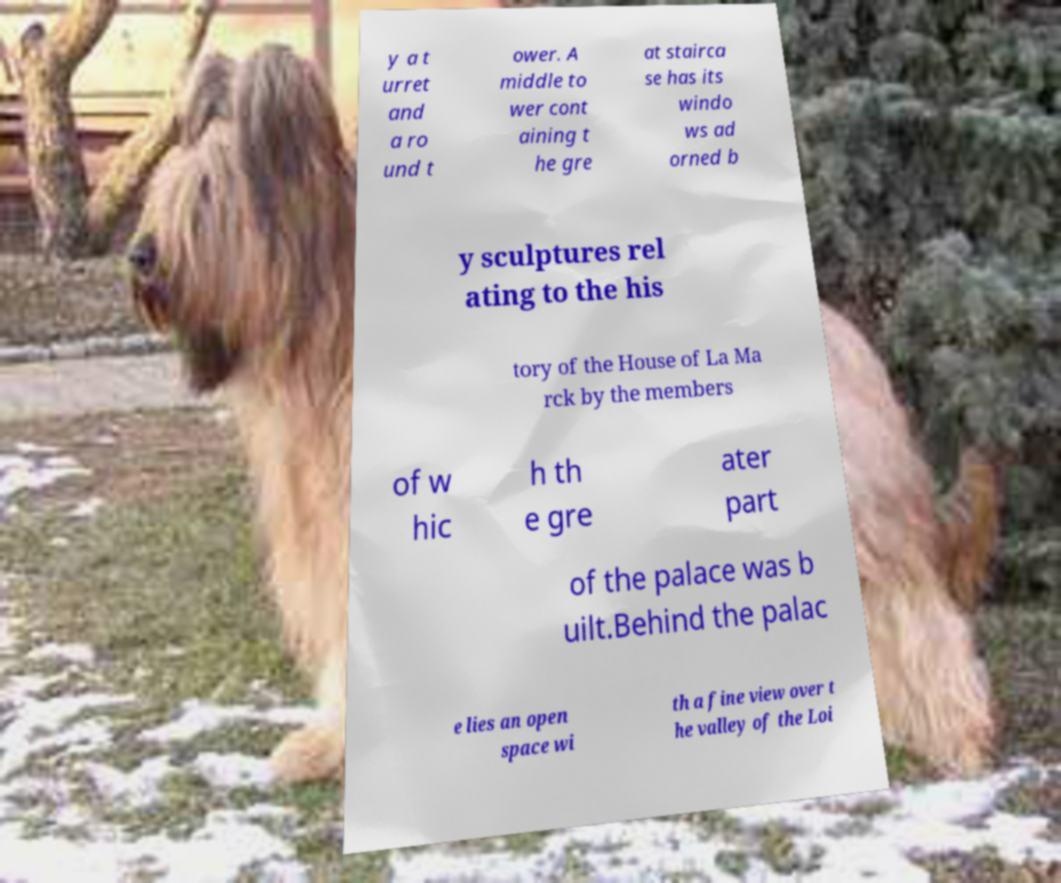There's text embedded in this image that I need extracted. Can you transcribe it verbatim? y a t urret and a ro und t ower. A middle to wer cont aining t he gre at stairca se has its windo ws ad orned b y sculptures rel ating to the his tory of the House of La Ma rck by the members of w hic h th e gre ater part of the palace was b uilt.Behind the palac e lies an open space wi th a fine view over t he valley of the Loi 